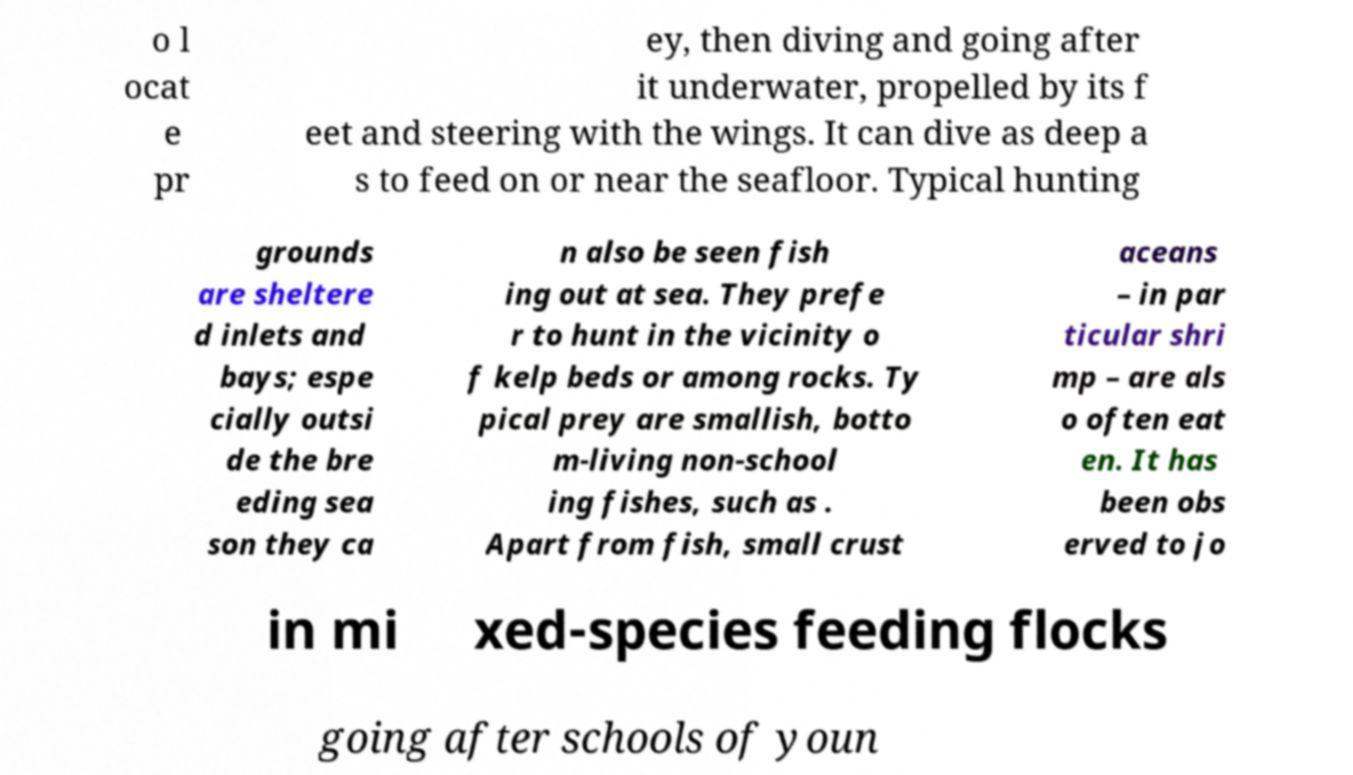There's text embedded in this image that I need extracted. Can you transcribe it verbatim? o l ocat e pr ey, then diving and going after it underwater, propelled by its f eet and steering with the wings. It can dive as deep a s to feed on or near the seafloor. Typical hunting grounds are sheltere d inlets and bays; espe cially outsi de the bre eding sea son they ca n also be seen fish ing out at sea. They prefe r to hunt in the vicinity o f kelp beds or among rocks. Ty pical prey are smallish, botto m-living non-school ing fishes, such as . Apart from fish, small crust aceans – in par ticular shri mp – are als o often eat en. It has been obs erved to jo in mi xed-species feeding flocks going after schools of youn 